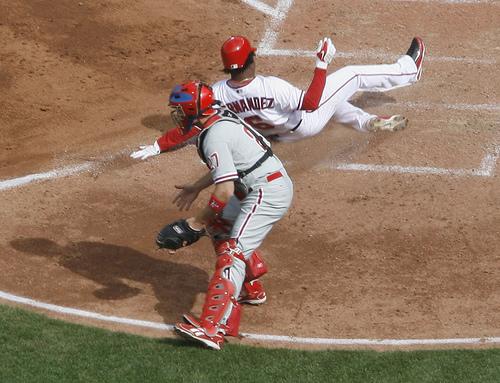What sport is this?
Answer briefly. Baseball. What is the last name of the player on the ground?
Answer briefly. Hernandez. What color are the baseball players hats?
Be succinct. Red. 